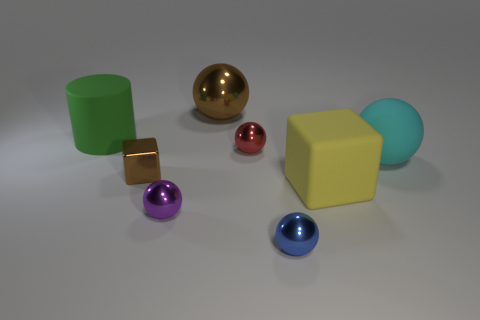What number of brown things are tiny cubes or large metallic spheres?
Your answer should be compact. 2. What shape is the rubber object that is to the left of the tiny metal object in front of the purple shiny ball?
Offer a terse response. Cylinder. There is a cube behind the large rubber cube; is it the same size as the blue sphere right of the large green matte thing?
Your response must be concise. Yes. Is there a small brown block that has the same material as the big brown ball?
Offer a terse response. Yes. What is the size of the object that is the same color as the tiny cube?
Offer a very short reply. Large. Is there a object behind the big sphere that is in front of the large thing that is behind the big green object?
Offer a very short reply. Yes. Are there any tiny metal objects in front of the large cyan ball?
Keep it short and to the point. Yes. How many large yellow objects are behind the large matte thing in front of the tiny brown metal block?
Offer a terse response. 0. There is a yellow thing; does it have the same size as the red metallic thing that is on the left side of the big cyan sphere?
Ensure brevity in your answer.  No. Are there any objects of the same color as the shiny block?
Ensure brevity in your answer.  Yes. 